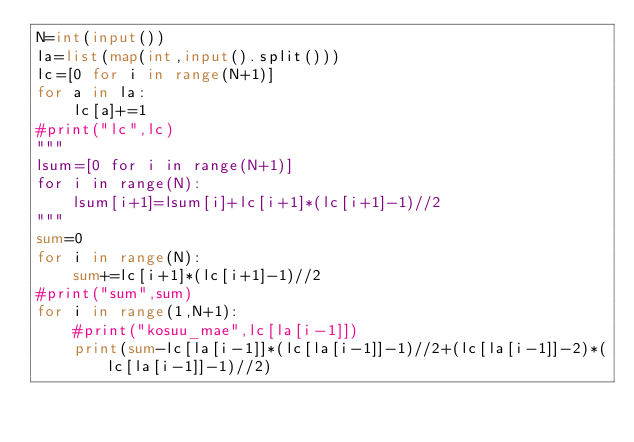<code> <loc_0><loc_0><loc_500><loc_500><_Python_>N=int(input())
la=list(map(int,input().split()))
lc=[0 for i in range(N+1)]
for a in la:
    lc[a]+=1
#print("lc",lc)
"""
lsum=[0 for i in range(N+1)]
for i in range(N):
    lsum[i+1]=lsum[i]+lc[i+1]*(lc[i+1]-1)//2
"""
sum=0
for i in range(N):
    sum+=lc[i+1]*(lc[i+1]-1)//2
#print("sum",sum)
for i in range(1,N+1):
    #print("kosuu_mae",lc[la[i-1]])
    print(sum-lc[la[i-1]]*(lc[la[i-1]]-1)//2+(lc[la[i-1]]-2)*(lc[la[i-1]]-1)//2)
</code> 